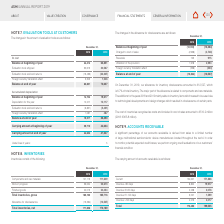According to Asm International Nv's financial document, How does the company monitor potential expected credit losses? perform ongoing credit evaluations of our customers’ financial condition. The document states: "to monitor potential expected credit losses, we perform ongoing credit evaluations of our customers’ financial condition...." Also, What are the time frames of carrying amount of accounts receivable? The document contains multiple relevant values: Current, Overdue <30 days, Overdue 31-60 days, Overdue 61-120 days, Overdue >120 days. From the document: "Current 154,607 171,866 Overdue 61-120 days 3,507 1,599 Overdue 31-60 days 2,258 2,076 Overdue >120 days 4,276 4,017 Overdue <30 days 8,802 19,977..." Also, What is the Current 2019 carrying amount of accounts receivable? According to the financial document, 171,866. The relevant text states: "Current 154,607 171,866..." Additionally, What is the time period with the greatest carrying amount of accounts receivable for 2019? According to the financial document, Current. The relevant text states: "Current 154,607 171,866..." Also, can you calculate: What is the percentage change in total carrying amount of accounts receivable from 2018 to 2019? To answer this question, I need to perform calculations using the financial data. The calculation is: ( 199,535 - 173,450 )/ 173,450 , which equals 15.04 (percentage). This is based on the information: "Total 173,450 199,535 Total 173,450 199,535..." The key data points involved are: 173,450, 199,535. Also, can you calculate: What is the change in current carrying amount of accounts receivable for 2018 to 2019? Based on the calculation:  171,866 - 154,607 , the result is 17259. This is based on the information: "Current 154,607 171,866 Current 154,607 171,866..." The key data points involved are: 154,607, 171,866. 